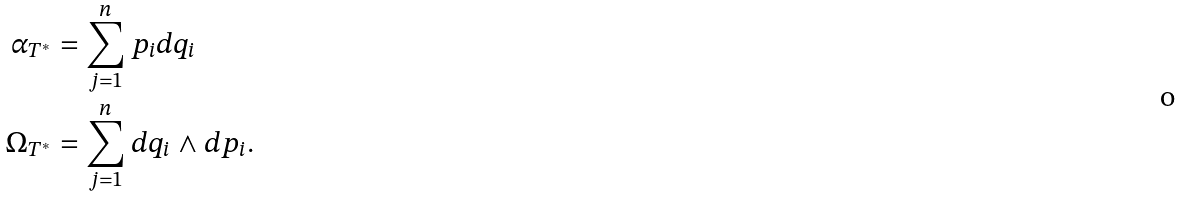Convert formula to latex. <formula><loc_0><loc_0><loc_500><loc_500>\alpha _ { T ^ { * } } & = \sum _ { j = 1 } ^ { n } p _ { i } d q _ { i } \\ \Omega _ { T ^ { * } } & = \sum _ { j = 1 } ^ { n } d q _ { i } \wedge d p _ { i } .</formula> 